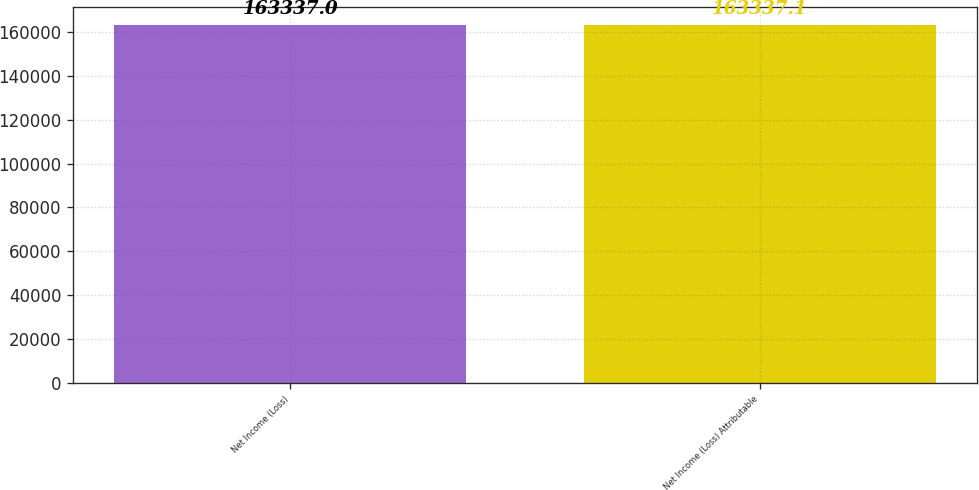Convert chart. <chart><loc_0><loc_0><loc_500><loc_500><bar_chart><fcel>Net Income (Loss)<fcel>Net Income (Loss) Attributable<nl><fcel>163337<fcel>163337<nl></chart> 